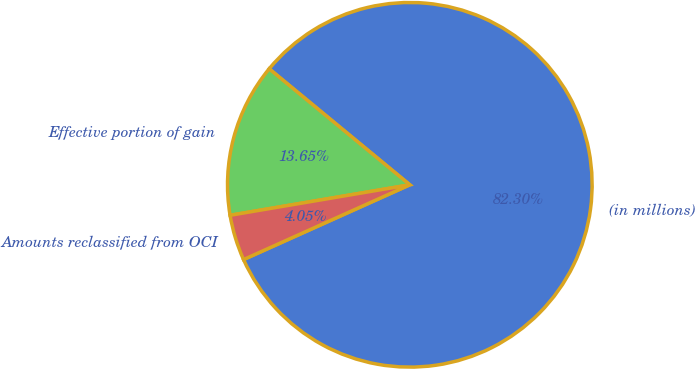Convert chart. <chart><loc_0><loc_0><loc_500><loc_500><pie_chart><fcel>(in millions)<fcel>Effective portion of gain<fcel>Amounts reclassified from OCI<nl><fcel>82.3%<fcel>13.65%<fcel>4.05%<nl></chart> 